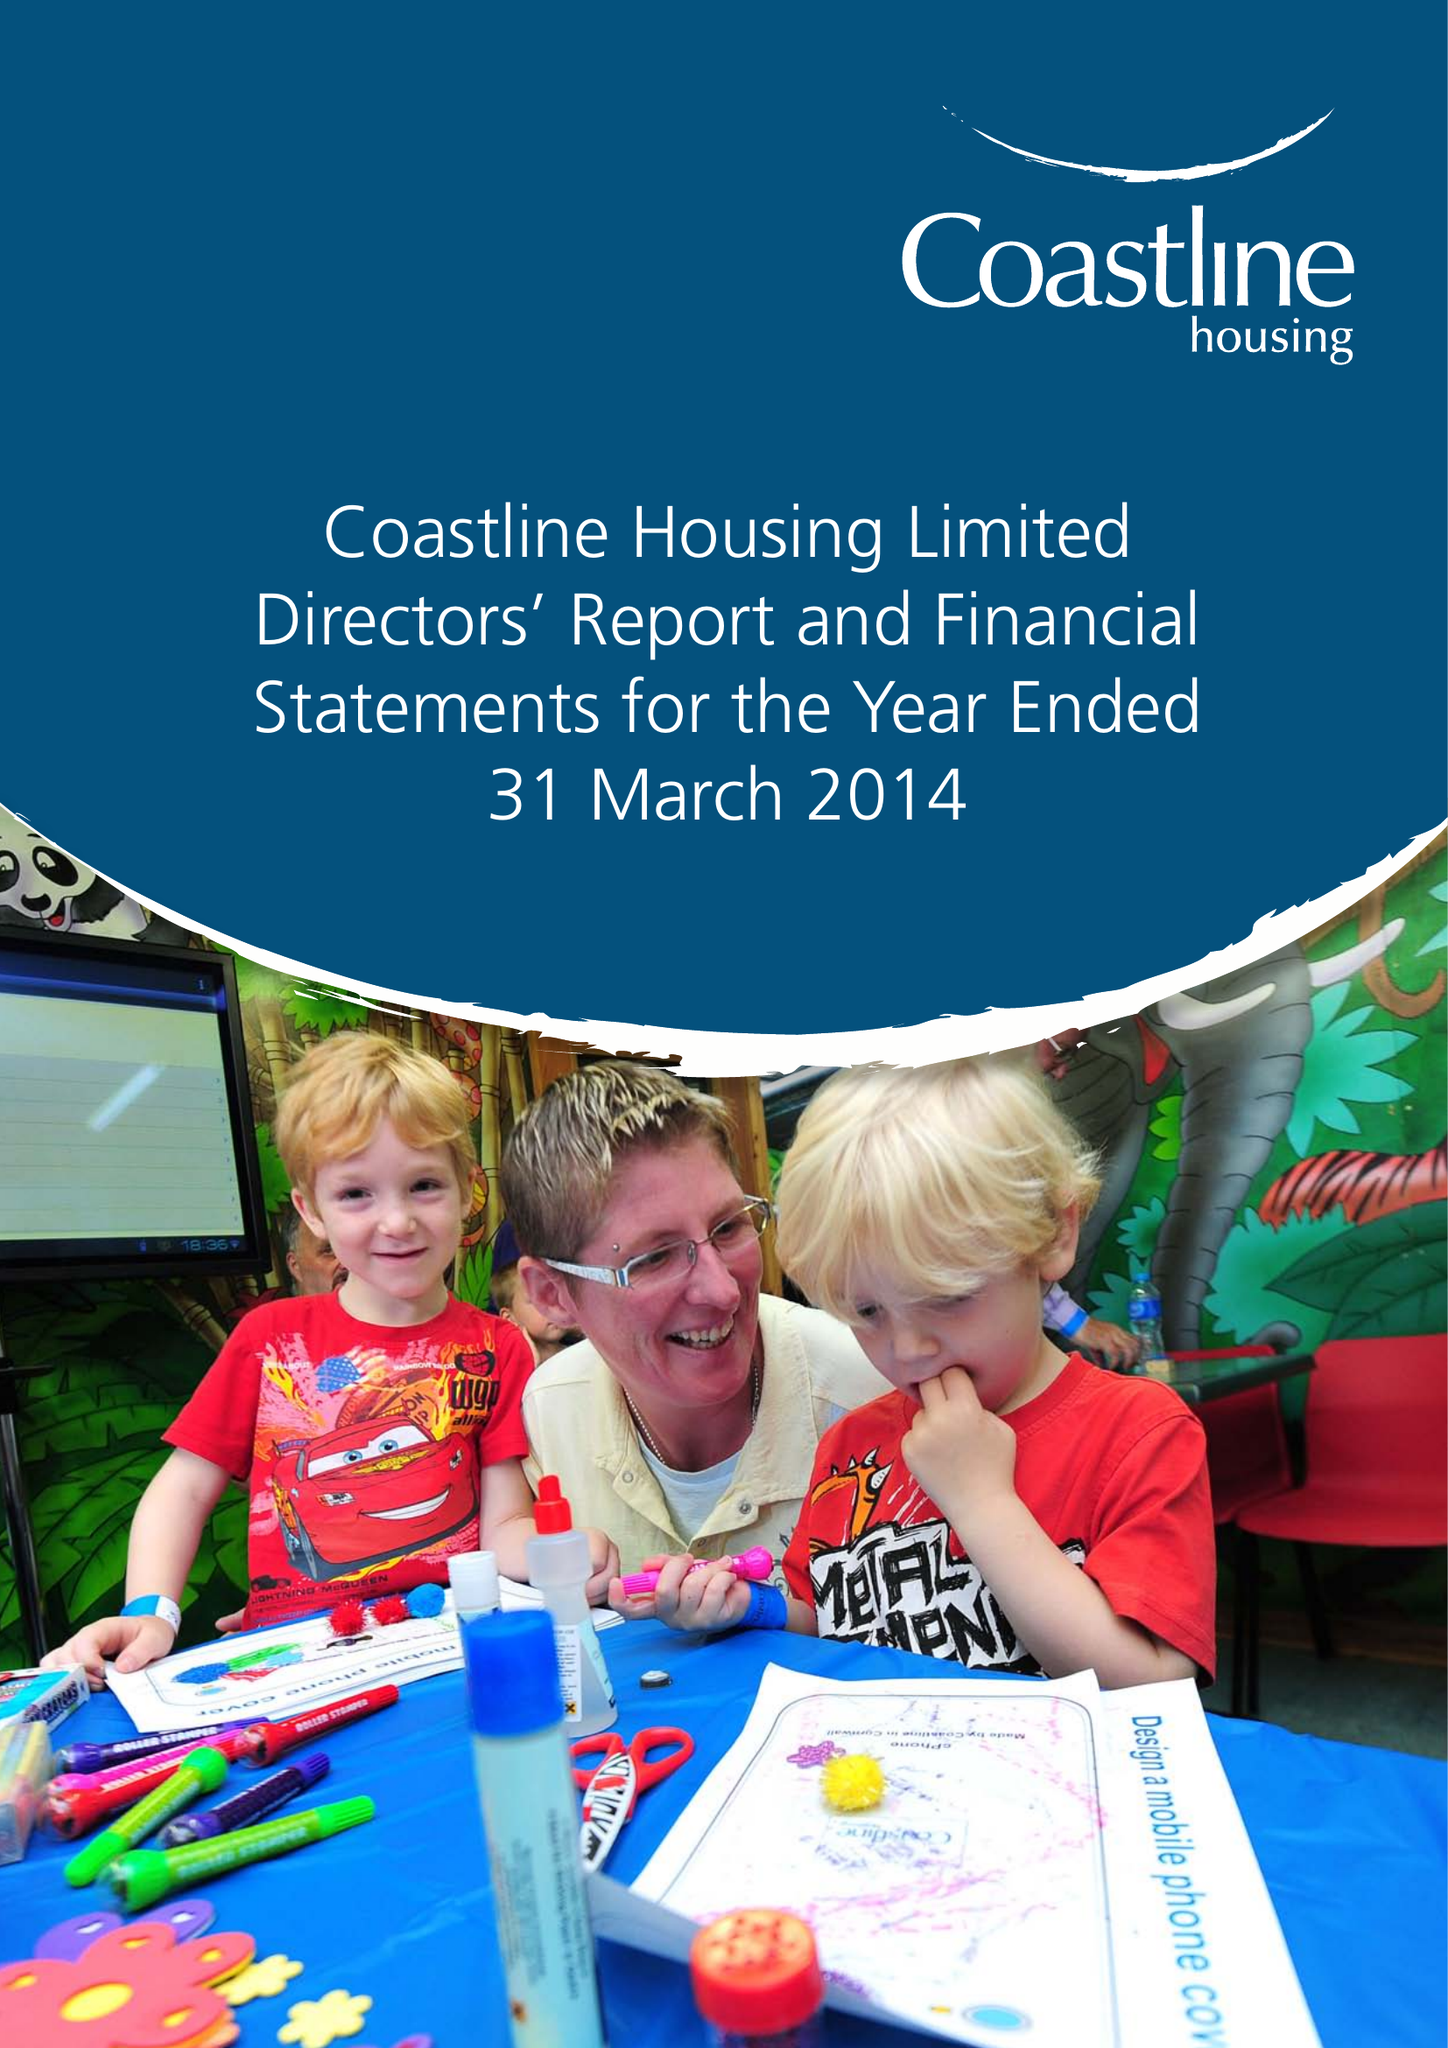What is the value for the report_date?
Answer the question using a single word or phrase. 2014-03-31 